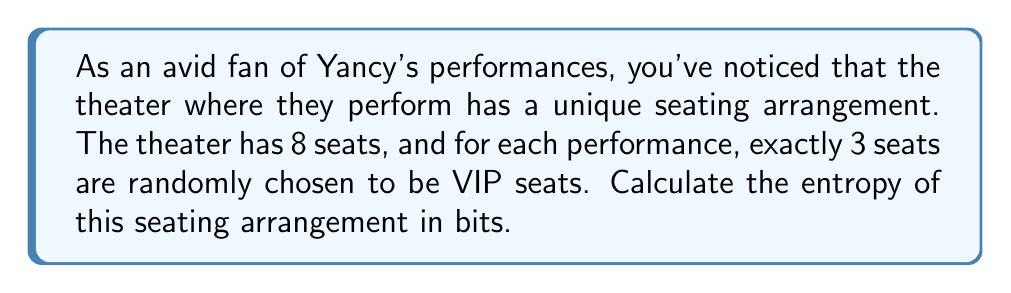Show me your answer to this math problem. To calculate the entropy of this seating arrangement, we need to follow these steps:

1) First, let's determine the total number of possible seating arrangements. This is a combination problem, as we're selecting 3 VIP seats out of 8 total seats. The number of possibilities is:

   $$\binom{8}{3} = \frac{8!}{3!(8-3)!} = \frac{8!}{3!5!} = 56$$

2) Now, since each of these arrangements is equally likely, the probability of each arrangement is:

   $$p = \frac{1}{56}$$

3) The entropy formula for a discrete uniform distribution is:

   $$H = -\sum_{i=1}^{n} p_i \log_2(p_i) = -n \cdot p \log_2(p)$$

   Where n is the number of possible outcomes, which in this case is 56.

4) Substituting our values:

   $$H = -56 \cdot \frac{1}{56} \log_2(\frac{1}{56})$$

5) Simplifying:

   $$H = -\log_2(\frac{1}{56}) = \log_2(56)$$

6) Calculate the final value:

   $$H = \log_2(56) \approx 5.807 \text{ bits}$$

This means that on average, about 5.807 bits of information are needed to specify a particular seating arrangement in this theater.
Answer: $5.807 \text{ bits}$ 